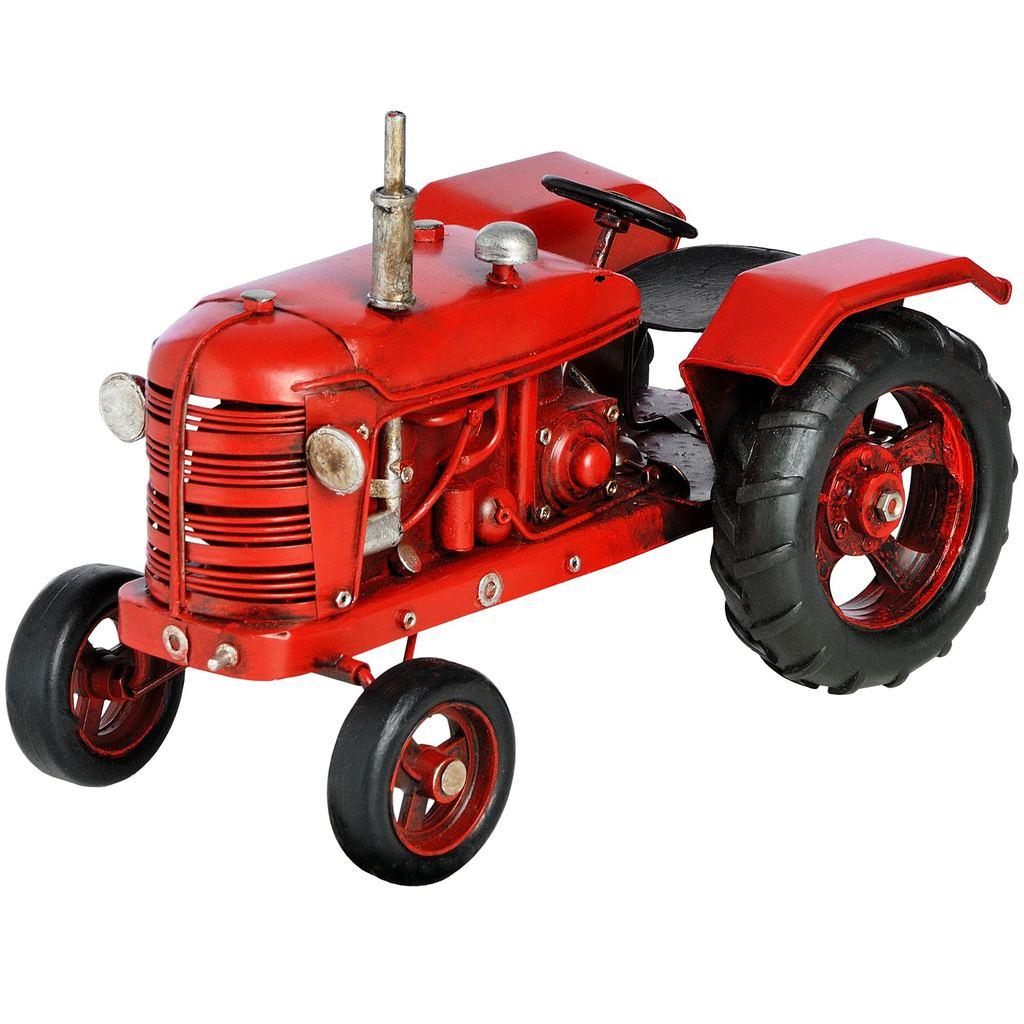What is the main subject of the image? The main subject of the image is a red-colored tractor. What color is the tractor in the image? The tractor is red in color. What can be seen in the background of the image? The background of the image is white in color. What type of spoon is being used to serve the food in the image? There is no spoon or food present in the image; it features a red-colored tractor with a white background. Can you tell me how many hooks are attached to the tractor in the image? There are no hooks visible on the tractor in the image. 